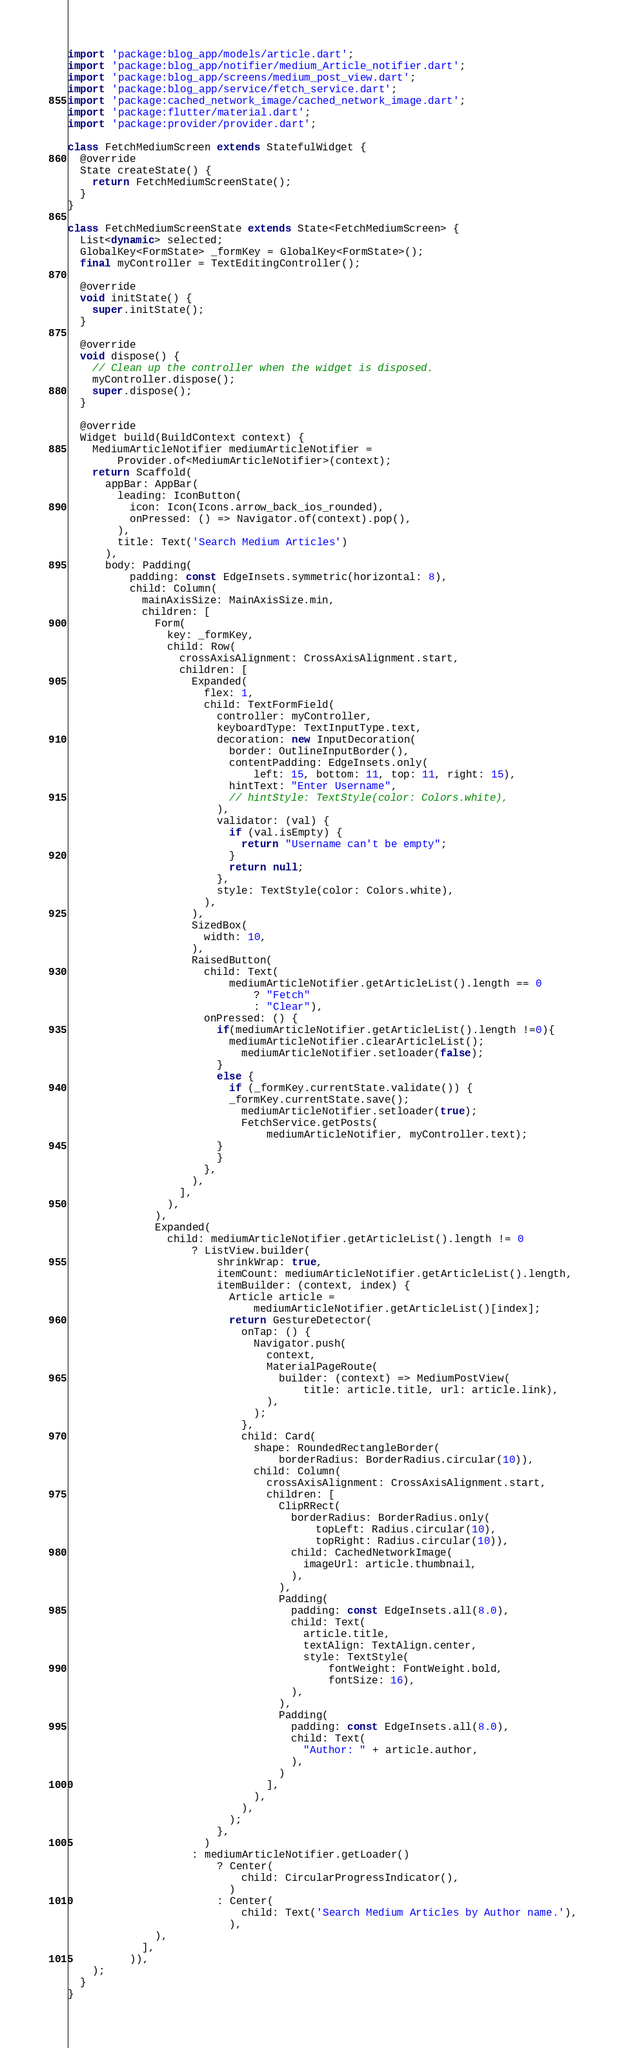Convert code to text. <code><loc_0><loc_0><loc_500><loc_500><_Dart_>import 'package:blog_app/models/article.dart';
import 'package:blog_app/notifier/medium_Article_notifier.dart';
import 'package:blog_app/screens/medium_post_view.dart';
import 'package:blog_app/service/fetch_service.dart';
import 'package:cached_network_image/cached_network_image.dart';
import 'package:flutter/material.dart';
import 'package:provider/provider.dart';

class FetchMediumScreen extends StatefulWidget {
  @override
  State createState() {
    return FetchMediumScreenState();
  }
}

class FetchMediumScreenState extends State<FetchMediumScreen> {
  List<dynamic> selected;
  GlobalKey<FormState> _formKey = GlobalKey<FormState>();
  final myController = TextEditingController();

  @override
  void initState() {
    super.initState();
  }

  @override
  void dispose() {
    // Clean up the controller when the widget is disposed.
    myController.dispose();
    super.dispose();
  }

  @override
  Widget build(BuildContext context) {
    MediumArticleNotifier mediumArticleNotifier =
        Provider.of<MediumArticleNotifier>(context);
    return Scaffold(
      appBar: AppBar(
        leading: IconButton(
          icon: Icon(Icons.arrow_back_ios_rounded),
          onPressed: () => Navigator.of(context).pop(),
        ),
        title: Text('Search Medium Articles')
      ),
      body: Padding(
          padding: const EdgeInsets.symmetric(horizontal: 8),
          child: Column(
            mainAxisSize: MainAxisSize.min,
            children: [
              Form(
                key: _formKey,
                child: Row(
                  crossAxisAlignment: CrossAxisAlignment.start,
                  children: [
                    Expanded(
                      flex: 1,
                      child: TextFormField(
                        controller: myController,
                        keyboardType: TextInputType.text,
                        decoration: new InputDecoration(
                          border: OutlineInputBorder(),
                          contentPadding: EdgeInsets.only(
                              left: 15, bottom: 11, top: 11, right: 15),
                          hintText: "Enter Username",
                          // hintStyle: TextStyle(color: Colors.white),
                        ),
                        validator: (val) {
                          if (val.isEmpty) {
                            return "Username can't be empty";
                          }
                          return null;
                        },
                        style: TextStyle(color: Colors.white),
                      ),
                    ),
                    SizedBox(
                      width: 10,
                    ),
                    RaisedButton(
                      child: Text(
                          mediumArticleNotifier.getArticleList().length == 0
                              ? "Fetch"
                              : "Clear"),
                      onPressed: () {
                        if(mediumArticleNotifier.getArticleList().length !=0){
                          mediumArticleNotifier.clearArticleList();
                            mediumArticleNotifier.setloader(false);
                        }
                        else {
                          if (_formKey.currentState.validate()) {
                          _formKey.currentState.save();
                            mediumArticleNotifier.setloader(true);
                            FetchService.getPosts(
                                mediumArticleNotifier, myController.text);
                        }
                        }
                      },
                    ),
                  ],
                ),
              ),
              Expanded(
                child: mediumArticleNotifier.getArticleList().length != 0
                    ? ListView.builder(
                        shrinkWrap: true,
                        itemCount: mediumArticleNotifier.getArticleList().length,
                        itemBuilder: (context, index) {
                          Article article =
                              mediumArticleNotifier.getArticleList()[index];
                          return GestureDetector(
                            onTap: () {
                              Navigator.push(
                                context,
                                MaterialPageRoute(
                                  builder: (context) => MediumPostView(
                                      title: article.title, url: article.link),
                                ),
                              );
                            },
                            child: Card(
                              shape: RoundedRectangleBorder(
                                  borderRadius: BorderRadius.circular(10)),
                              child: Column(
                                crossAxisAlignment: CrossAxisAlignment.start,
                                children: [
                                  ClipRRect(
                                    borderRadius: BorderRadius.only(
                                        topLeft: Radius.circular(10),
                                        topRight: Radius.circular(10)),
                                    child: CachedNetworkImage(
                                      imageUrl: article.thumbnail,
                                    ),
                                  ),
                                  Padding(
                                    padding: const EdgeInsets.all(8.0),
                                    child: Text(
                                      article.title,
                                      textAlign: TextAlign.center,
                                      style: TextStyle(
                                          fontWeight: FontWeight.bold,
                                          fontSize: 16),
                                    ),
                                  ),
                                  Padding(
                                    padding: const EdgeInsets.all(8.0),
                                    child: Text(
                                      "Author: " + article.author,
                                    ),
                                  )
                                ],
                              ),
                            ),
                          );
                        },
                      )
                    : mediumArticleNotifier.getLoader()
                        ? Center(
                            child: CircularProgressIndicator(),
                          )
                        : Center(
                            child: Text('Search Medium Articles by Author name.'),
                          ),
              ),
            ],
          )),
    );
  }
}
</code> 